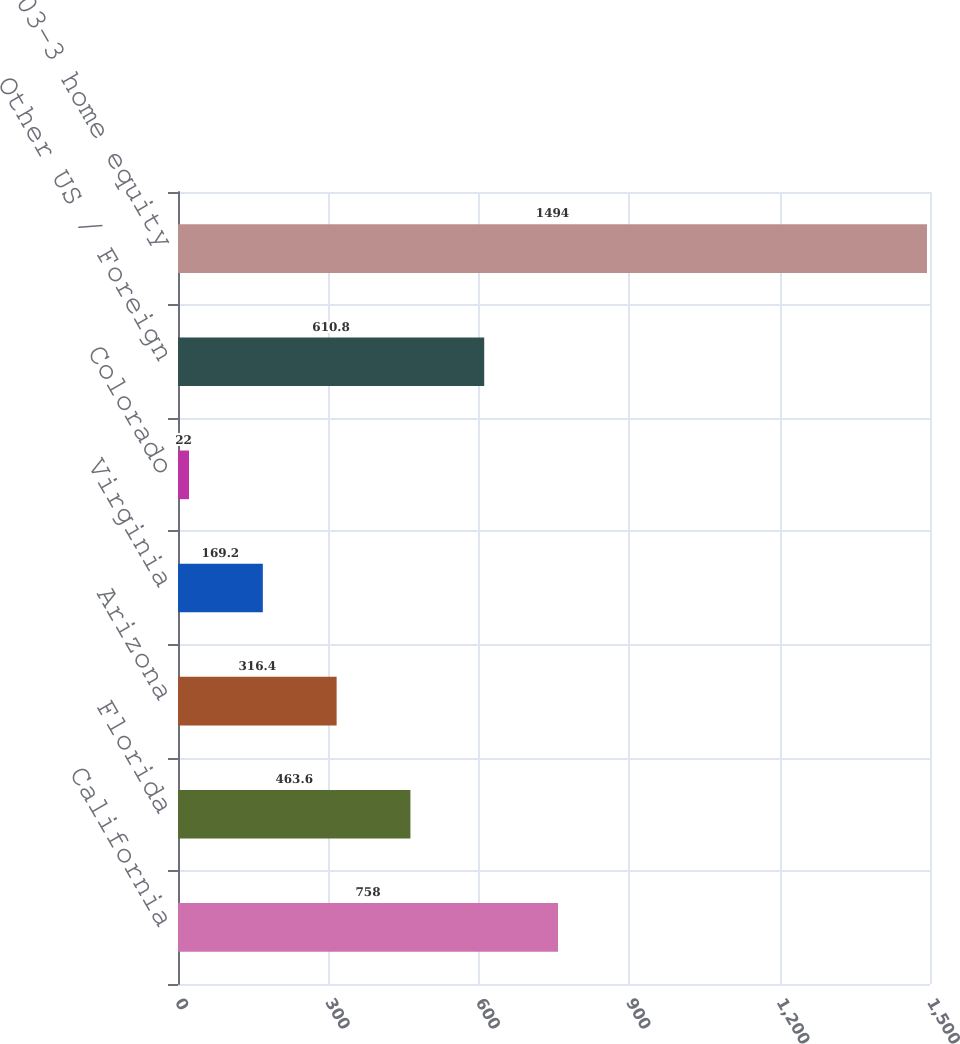Convert chart. <chart><loc_0><loc_0><loc_500><loc_500><bar_chart><fcel>California<fcel>Florida<fcel>Arizona<fcel>Virginia<fcel>Colorado<fcel>Other US / Foreign<fcel>Total SOP 03-3 home equity<nl><fcel>758<fcel>463.6<fcel>316.4<fcel>169.2<fcel>22<fcel>610.8<fcel>1494<nl></chart> 